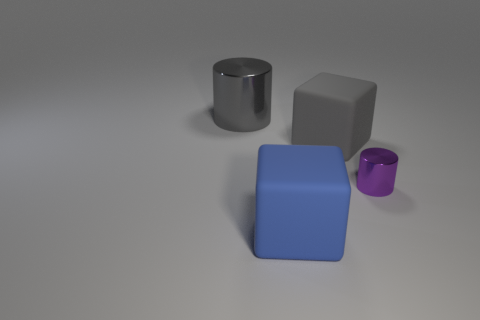Add 2 big metal objects. How many objects exist? 6 Subtract all purple rubber balls. Subtract all gray rubber cubes. How many objects are left? 3 Add 1 big blue blocks. How many big blue blocks are left? 2 Add 1 big cubes. How many big cubes exist? 3 Subtract 0 cyan spheres. How many objects are left? 4 